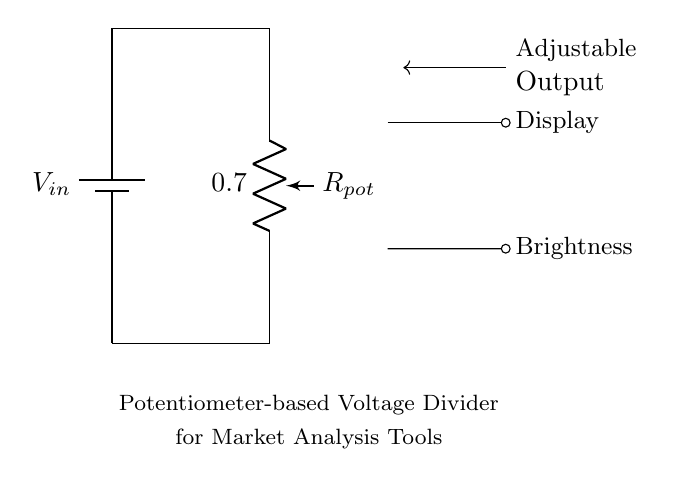What type of circuit is shown? The circuit is a voltage divider, specifically a potentiometer-based voltage divider which is designed to adjust output voltage.
Answer: voltage divider What component adjusts the brightness? The potentiometer is the component in the circuit that adjusts the output voltage, and thus the display brightness, by varying its resistance.
Answer: potentiometer What is the purpose of the battery in this circuit? The battery provides the input voltage necessary for the operation of the voltage divider. It establishes the potential difference required across the circuit.
Answer: input voltage How many terminals does the potentiometer have? A standard potentiometer has three terminals, which allow it to function correctly as a variable resistor in this application.
Answer: three What voltage does the adjustable output provide? The adjustable output voltage can vary between zero and the input voltage as the setting of the potentiometer is changed.
Answer: variable (0 to V in) How does changing the resistance affect the output voltage? By increasing the resistance of the potentiometer, the output voltage decreases, which results in a dimmer display; decreasing the resistance results in a brighter display.
Answer: output voltage decreases What type of display is being adjusted? The circuit is used to adjust the brightness of a display, which can be a screen or panel in market analysis presentation tools.
Answer: display 